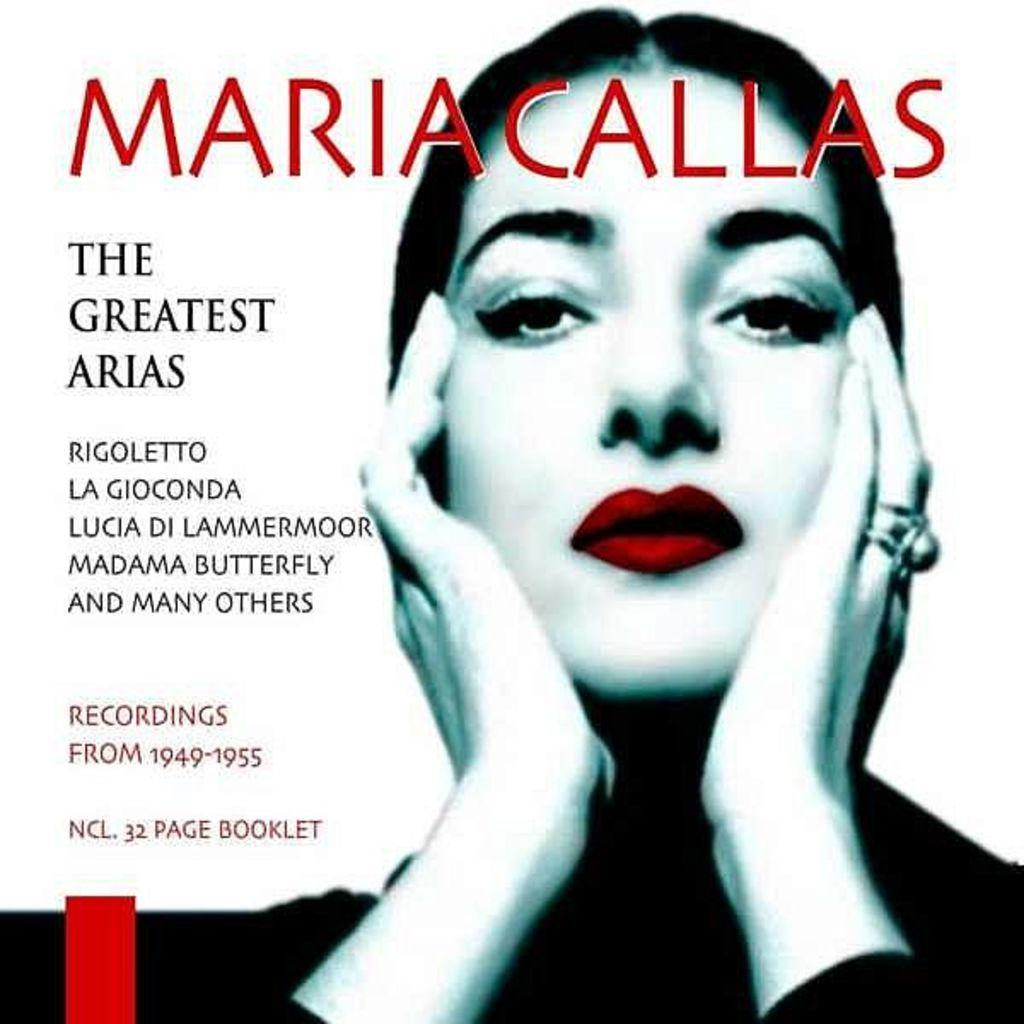What object can be seen in the picture? There is a book in the picture. Who is the main subject in the center of the picture? There is a woman in the center of the picture. What can be found on the book? There is text written on the book. How many rabbits are present in the picture? There are no rabbits present in the picture. What type of clothing is the girl wearing in the picture? There is no girl present in the picture; it features a woman. 